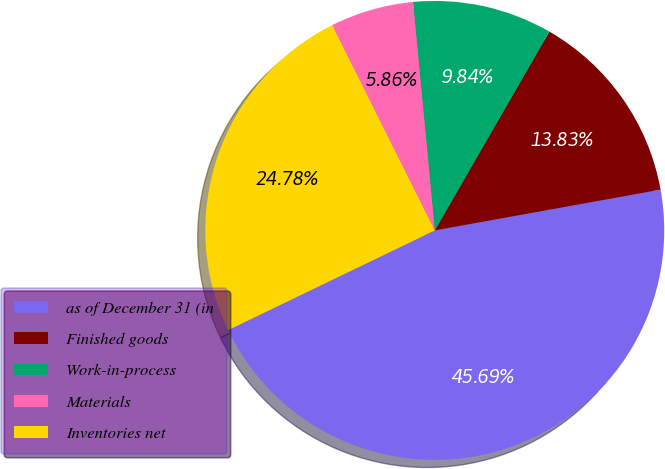<chart> <loc_0><loc_0><loc_500><loc_500><pie_chart><fcel>as of December 31 (in<fcel>Finished goods<fcel>Work-in-process<fcel>Materials<fcel>Inventories net<nl><fcel>45.69%<fcel>13.83%<fcel>9.84%<fcel>5.86%<fcel>24.78%<nl></chart> 